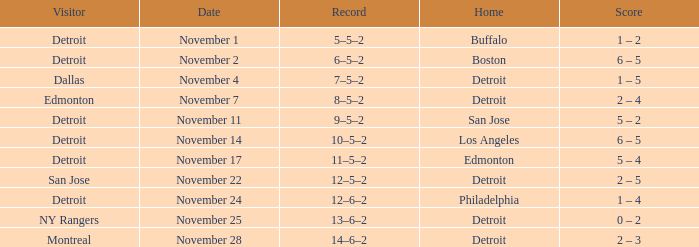Which visitor has a Los Angeles home? Detroit. Could you parse the entire table? {'header': ['Visitor', 'Date', 'Record', 'Home', 'Score'], 'rows': [['Detroit', 'November 1', '5–5–2', 'Buffalo', '1 – 2'], ['Detroit', 'November 2', '6–5–2', 'Boston', '6 – 5'], ['Dallas', 'November 4', '7–5–2', 'Detroit', '1 – 5'], ['Edmonton', 'November 7', '8–5–2', 'Detroit', '2 – 4'], ['Detroit', 'November 11', '9–5–2', 'San Jose', '5 – 2'], ['Detroit', 'November 14', '10–5–2', 'Los Angeles', '6 – 5'], ['Detroit', 'November 17', '11–5–2', 'Edmonton', '5 – 4'], ['San Jose', 'November 22', '12–5–2', 'Detroit', '2 – 5'], ['Detroit', 'November 24', '12–6–2', 'Philadelphia', '1 – 4'], ['NY Rangers', 'November 25', '13–6–2', 'Detroit', '0 – 2'], ['Montreal', 'November 28', '14–6–2', 'Detroit', '2 – 3']]} 